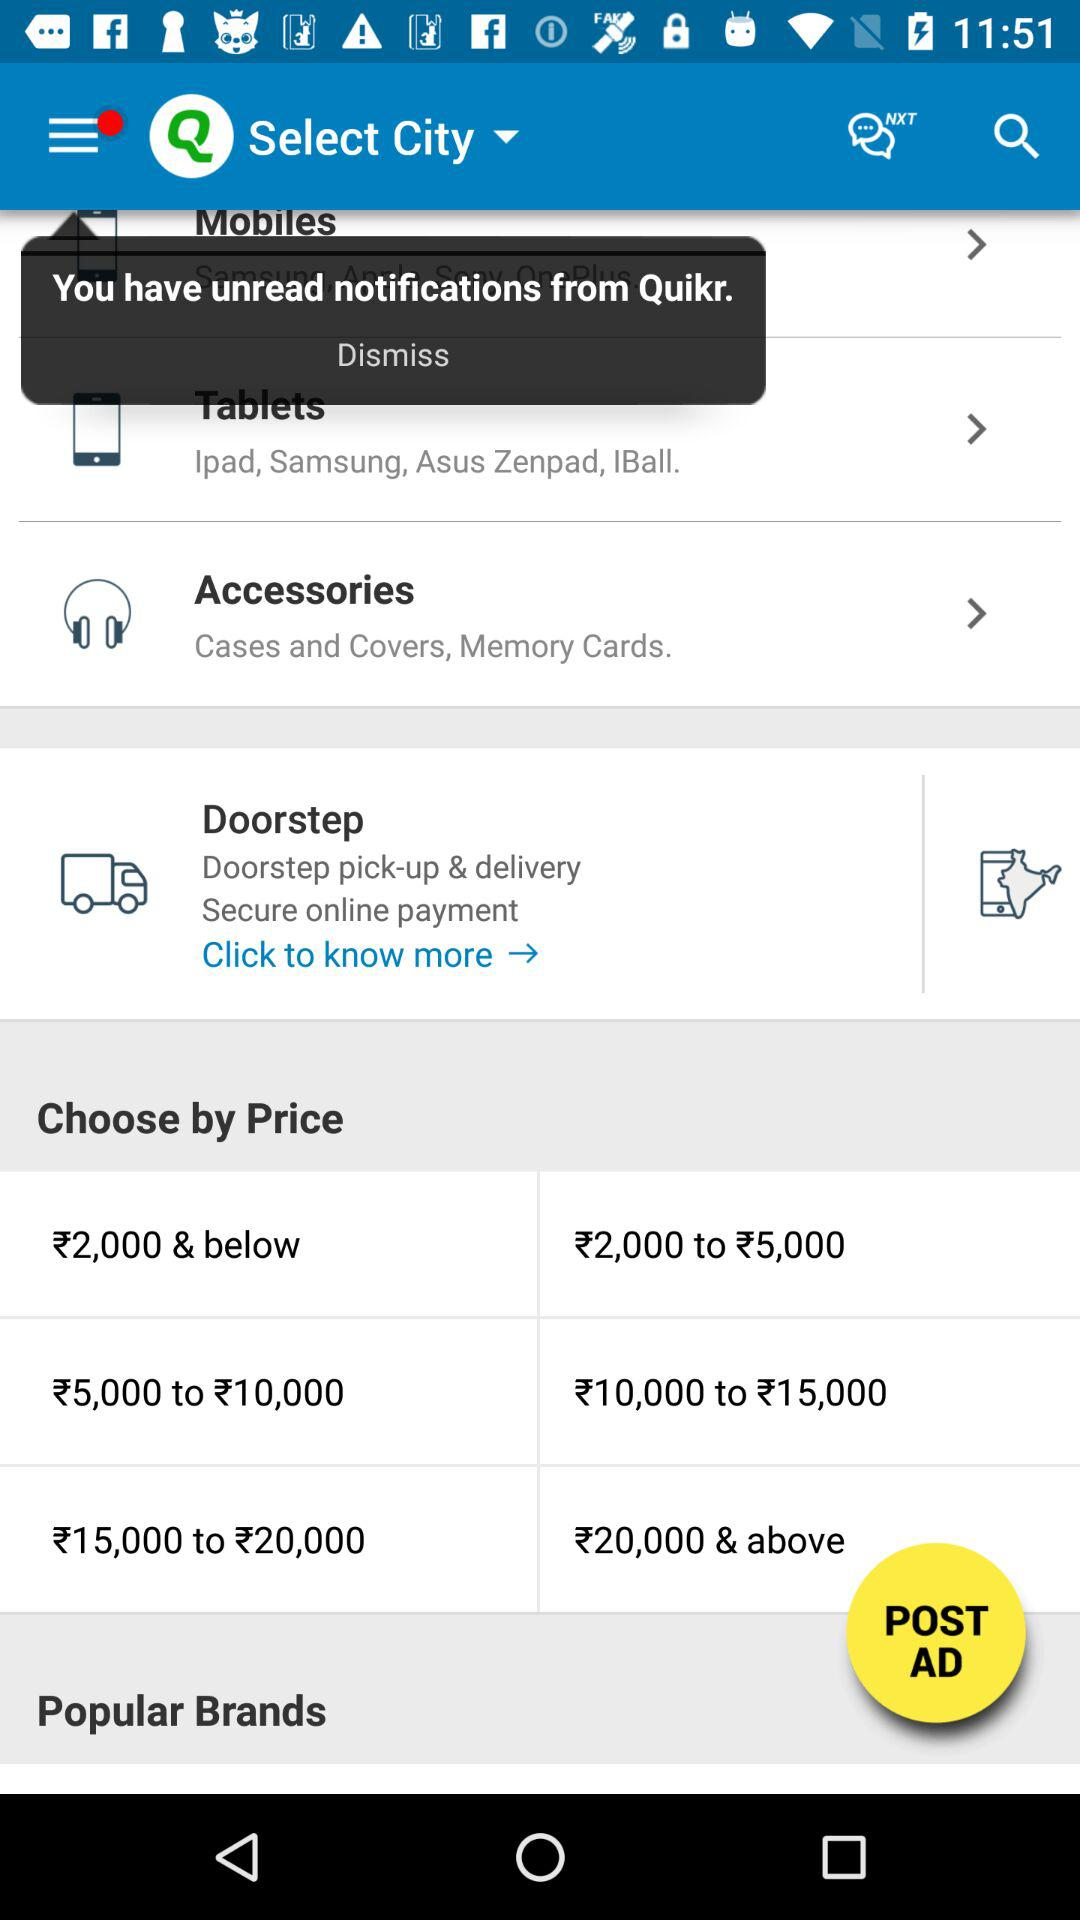What are the accessories? The accessories are cases, covers, and memory cards. 